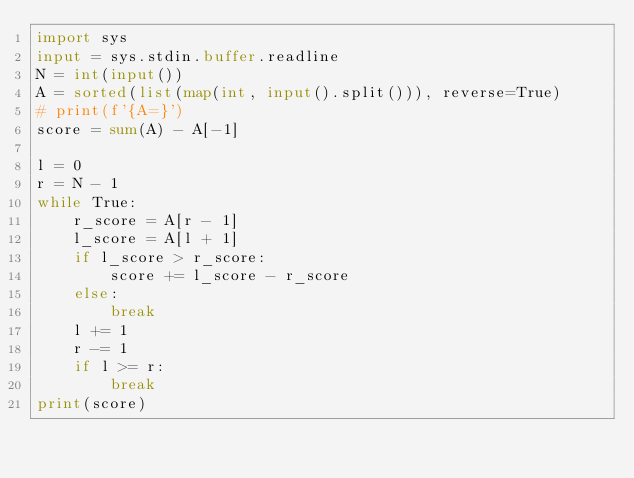Convert code to text. <code><loc_0><loc_0><loc_500><loc_500><_Python_>import sys
input = sys.stdin.buffer.readline
N = int(input())
A = sorted(list(map(int, input().split())), reverse=True)
# print(f'{A=}')
score = sum(A) - A[-1]

l = 0
r = N - 1
while True:
    r_score = A[r - 1]
    l_score = A[l + 1]
    if l_score > r_score:
        score += l_score - r_score
    else:
        break
    l += 1
    r -= 1
    if l >= r:
        break
print(score)
</code> 